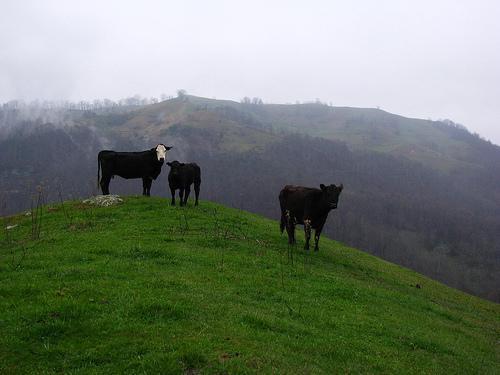How many cows are there?
Give a very brief answer. 3. 